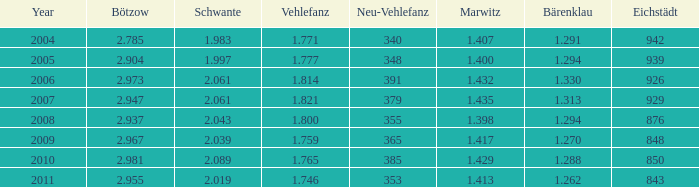What year has a Schwante smaller than 2.043, an Eichstädt smaller than 848, and a Bärenklau smaller than 1.262? 0.0. 